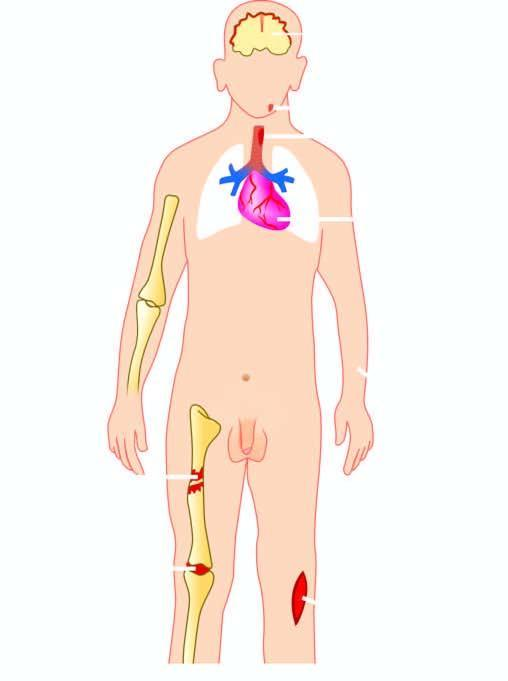what is caused by staphylococcus aureus?
Answer the question using a single word or phrase. Suppurative diseases 